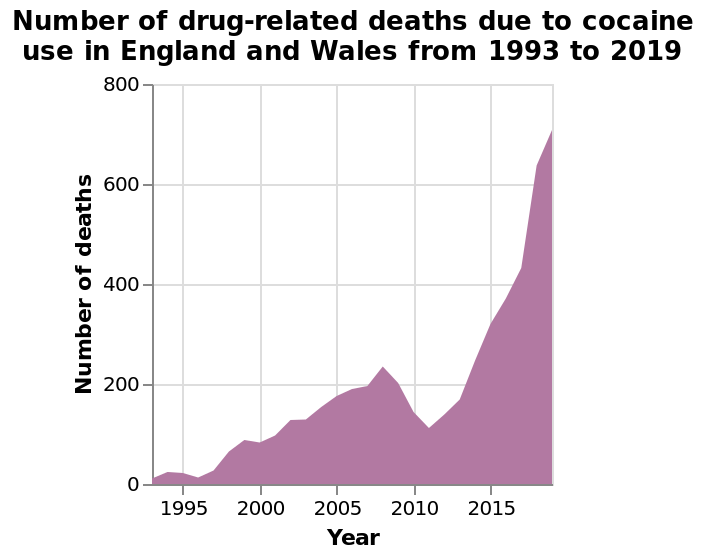<image>
What was the trend in drug related deaths due to cocaine in England and Wales between 1996 and 2020?  The number of drug related deaths due to cocaine in England and Wales rose steadily from 1996 to 2008, decreased between 2008-2011, and then dramatically increased after 2011. How did the number of drug related deaths due to cocaine change between 2008 and 2011?  The number of drug related deaths due to cocaine decreased between 2008 and 2011. What was the percentage increase in drug related deaths due to cocaine in England and Wales between 2017 and 2020?  The number of drug related deaths due to cocaine tripled from over 200 in 2017 to over 700 in 2020, resulting in a 250% increase. Describe the following image in detail This is a area plot called Number of drug-related deaths due to cocaine use in England and Wales from 1993 to 2019. A linear scale from 0 to 800 can be found on the y-axis, marked Number of deaths. Year is measured along a linear scale with a minimum of 1995 and a maximum of 2015 along the x-axis. 